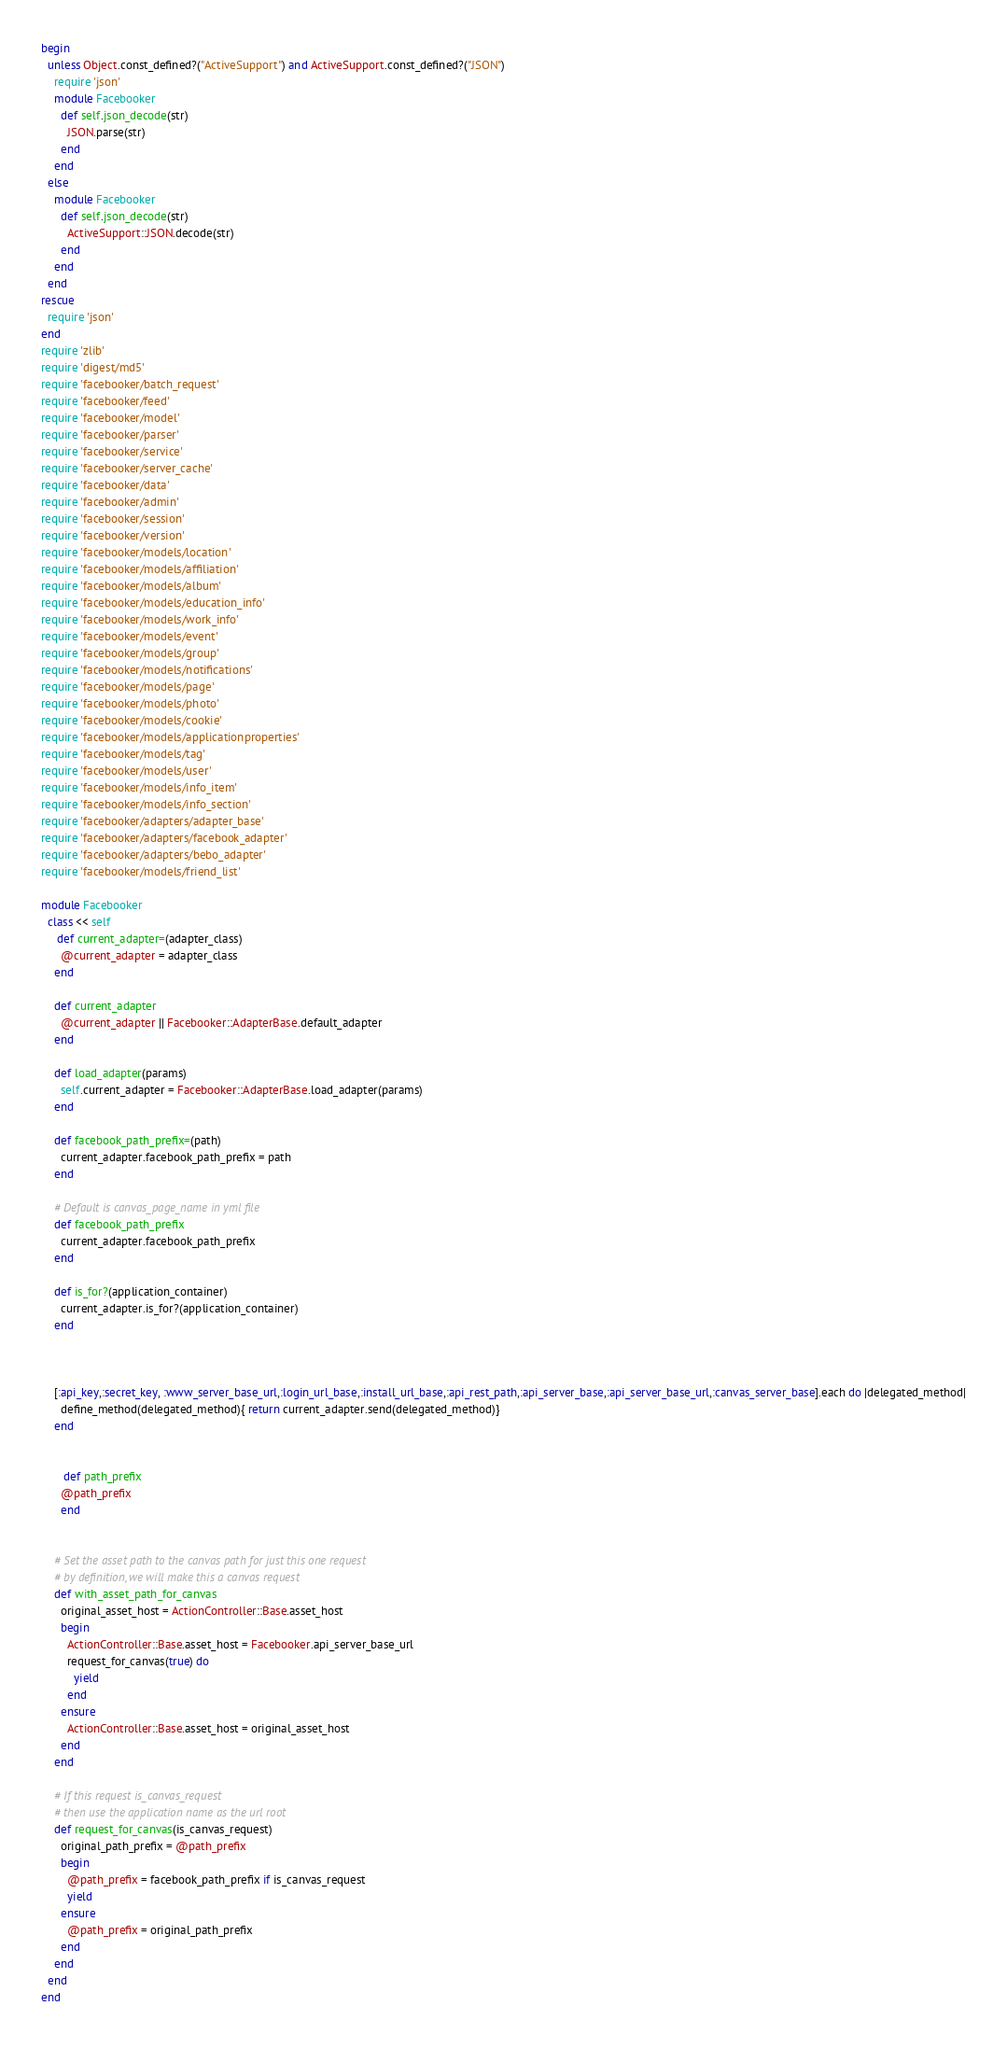Convert code to text. <code><loc_0><loc_0><loc_500><loc_500><_Ruby_>begin
  unless Object.const_defined?("ActiveSupport") and ActiveSupport.const_defined?("JSON")
    require 'json' 
    module Facebooker
      def self.json_decode(str)
        JSON.parse(str)
      end
    end
  else
    module Facebooker
      def self.json_decode(str)
        ActiveSupport::JSON.decode(str)
      end
    end
  end 
rescue
  require 'json' 
end
require 'zlib'
require 'digest/md5'
require 'facebooker/batch_request'
require 'facebooker/feed'
require 'facebooker/model'
require 'facebooker/parser'
require 'facebooker/service'
require 'facebooker/server_cache'
require 'facebooker/data'
require 'facebooker/admin'
require 'facebooker/session'
require 'facebooker/version'
require 'facebooker/models/location'
require 'facebooker/models/affiliation'
require 'facebooker/models/album'
require 'facebooker/models/education_info'
require 'facebooker/models/work_info'
require 'facebooker/models/event'
require 'facebooker/models/group'
require 'facebooker/models/notifications'
require 'facebooker/models/page'
require 'facebooker/models/photo'
require 'facebooker/models/cookie'
require 'facebooker/models/applicationproperties'
require 'facebooker/models/tag'
require 'facebooker/models/user'
require 'facebooker/models/info_item'
require 'facebooker/models/info_section'
require 'facebooker/adapters/adapter_base'
require 'facebooker/adapters/facebook_adapter'
require 'facebooker/adapters/bebo_adapter'
require 'facebooker/models/friend_list'

module Facebooker
  class << self
     def current_adapter=(adapter_class)
      @current_adapter = adapter_class
    end
    
    def current_adapter
      @current_adapter || Facebooker::AdapterBase.default_adapter
    end
    
    def load_adapter(params)
      self.current_adapter = Facebooker::AdapterBase.load_adapter(params)
    end
      
    def facebook_path_prefix=(path)
      current_adapter.facebook_path_prefix = path
    end
  
    # Default is canvas_page_name in yml file
    def facebook_path_prefix
      current_adapter.facebook_path_prefix
    end
    
    def is_for?(application_container)
      current_adapter.is_for?(application_container)
    end
    
   
   
    [:api_key,:secret_key, :www_server_base_url,:login_url_base,:install_url_base,:api_rest_path,:api_server_base,:api_server_base_url,:canvas_server_base].each do |delegated_method|
      define_method(delegated_method){ return current_adapter.send(delegated_method)}
    end
    
    
       def path_prefix
      @path_prefix
      end
    
    
    # Set the asset path to the canvas path for just this one request
    # by definition, we will make this a canvas request
    def with_asset_path_for_canvas
      original_asset_host = ActionController::Base.asset_host
      begin
        ActionController::Base.asset_host = Facebooker.api_server_base_url
        request_for_canvas(true) do
          yield
        end
      ensure
        ActionController::Base.asset_host = original_asset_host
      end
    end
  
    # If this request is_canvas_request
    # then use the application name as the url root
    def request_for_canvas(is_canvas_request)
      original_path_prefix = @path_prefix 
      begin
        @path_prefix = facebook_path_prefix if is_canvas_request
        yield
      ensure
        @path_prefix = original_path_prefix
      end
    end
  end
end
</code> 